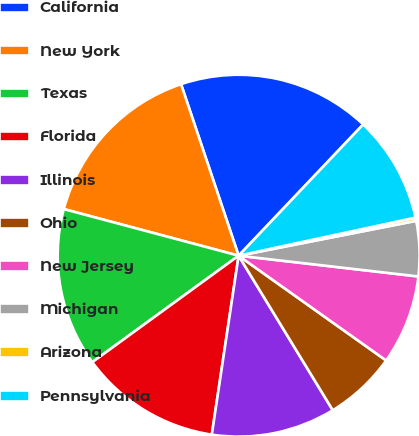<chart> <loc_0><loc_0><loc_500><loc_500><pie_chart><fcel>California<fcel>New York<fcel>Texas<fcel>Florida<fcel>Illinois<fcel>Ohio<fcel>New Jersey<fcel>Michigan<fcel>Arizona<fcel>Pennsylvania<nl><fcel>17.24%<fcel>15.7%<fcel>14.16%<fcel>12.62%<fcel>11.08%<fcel>6.46%<fcel>8.0%<fcel>4.92%<fcel>0.29%<fcel>9.54%<nl></chart> 